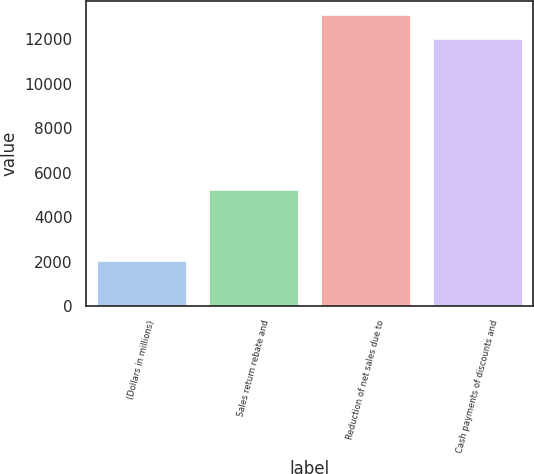<chart> <loc_0><loc_0><loc_500><loc_500><bar_chart><fcel>(Dollars in millions)<fcel>Sales return rebate and<fcel>Reduction of net sales due to<fcel>Cash payments of discounts and<nl><fcel>2018<fcel>5223.16<fcel>13074.6<fcel>12023.4<nl></chart> 